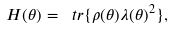<formula> <loc_0><loc_0><loc_500><loc_500>H ( \theta ) = \ t r \{ \rho ( \theta ) \lambda ( \theta ) ^ { 2 } \} ,</formula> 